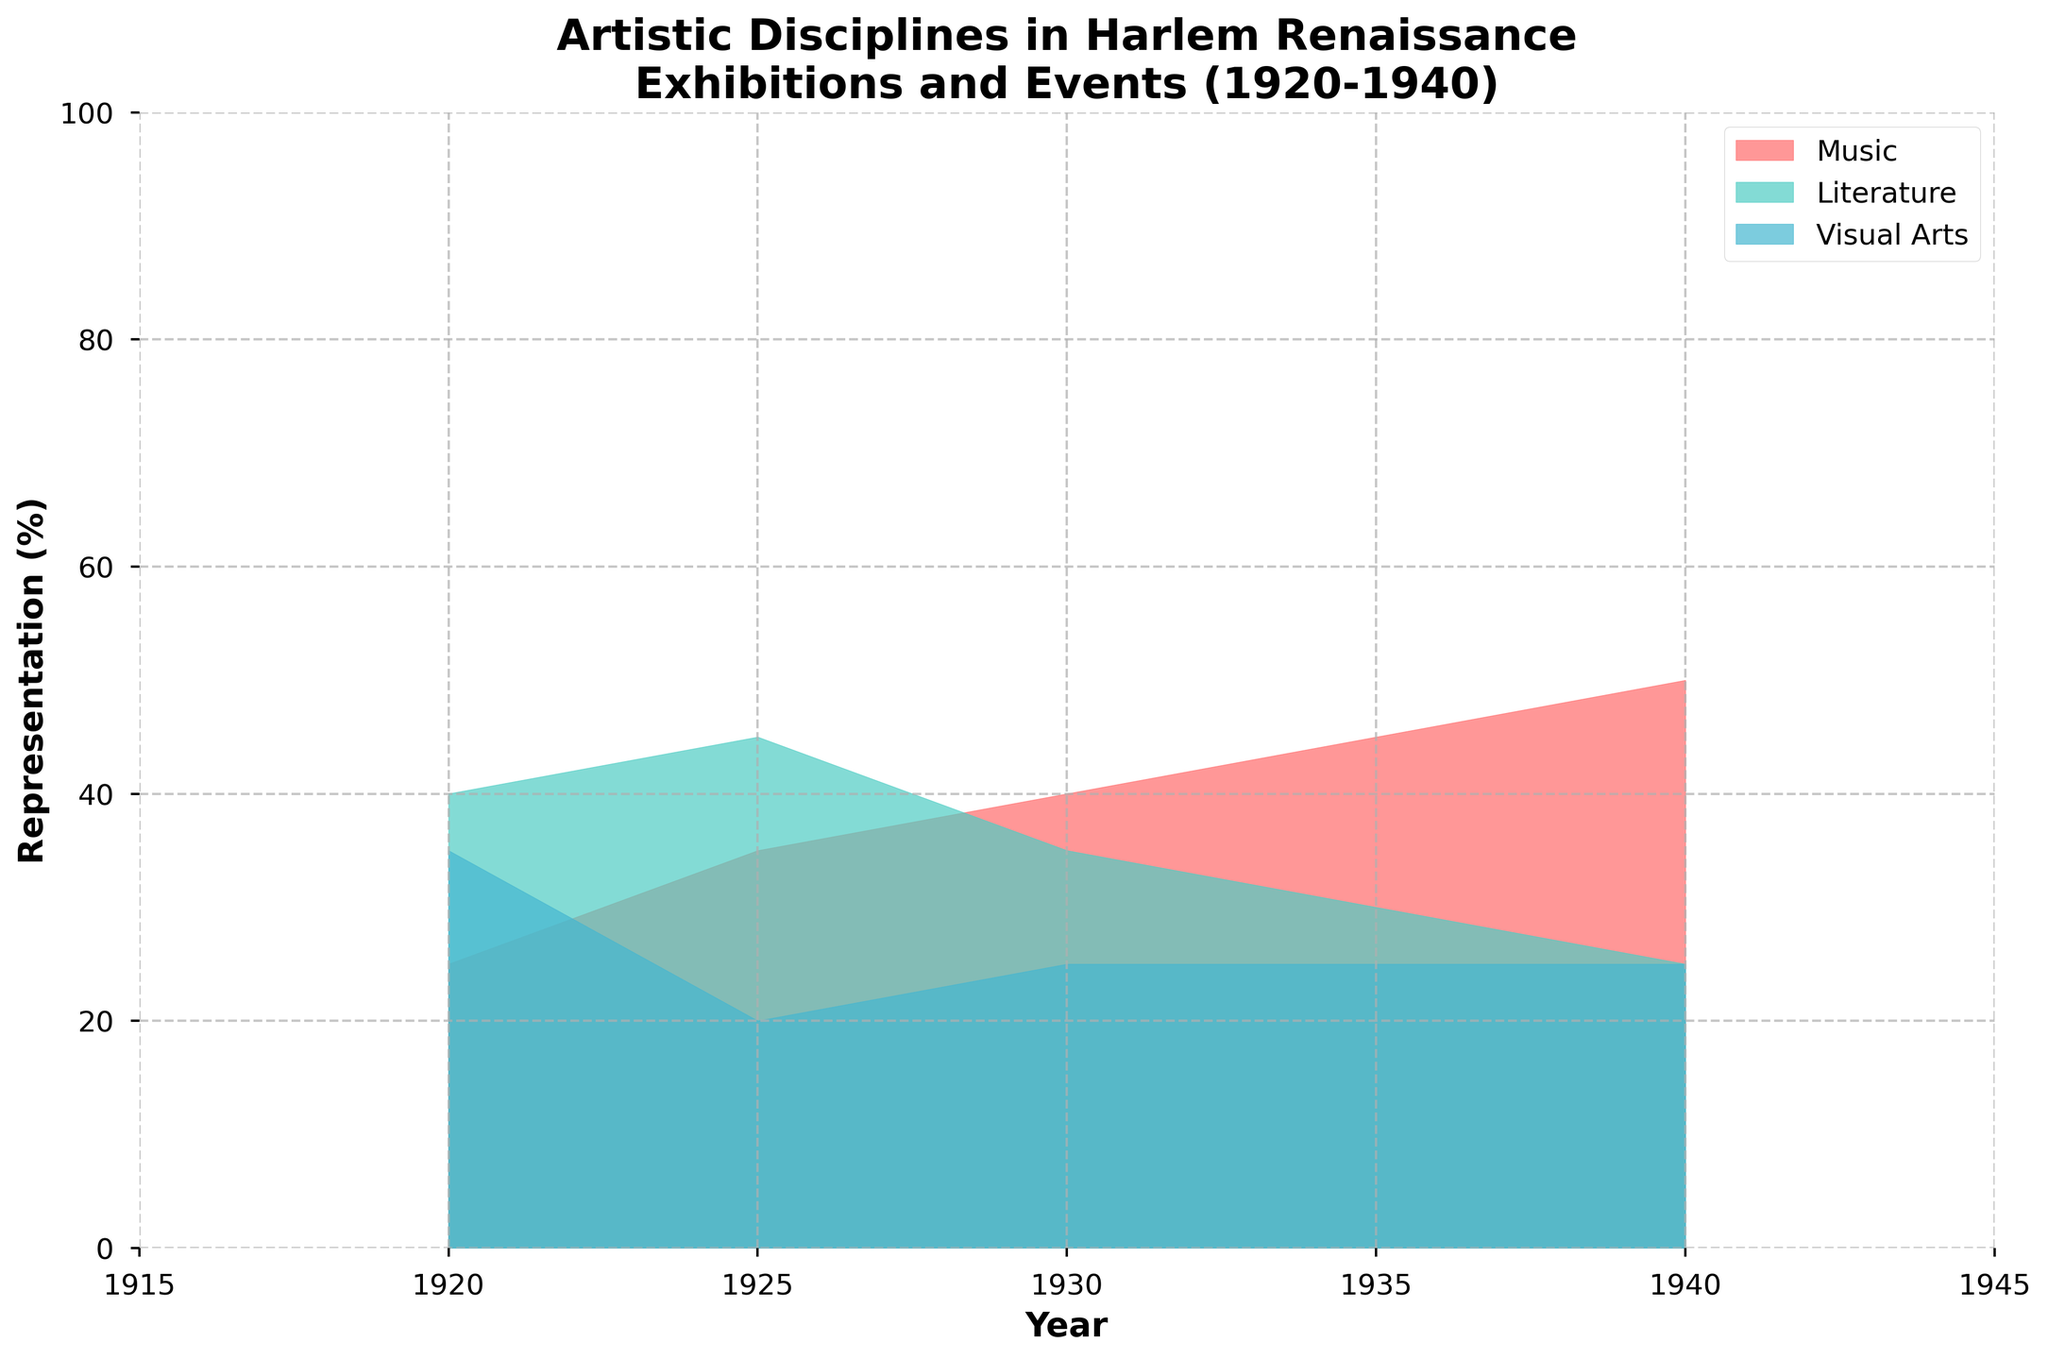What is the highest representation percentage across all disciplines in 1940? The maximum representation for any discipline in 1940 can be identified directly from the chart. The largest value observed is for Music at 50%.
Answer: 50% Which discipline had the lowest representation in 1925? By examining the representation values for each discipline in 1925, Music = 35%, Literature = 45%, Visual Arts = 20%. The lowest percentage is for Visual Arts.
Answer: Visual Arts What is the average representation of Literature in the given time period? Sum the representation values for Literature (40, 45, 35, 30, 25) and then divide by the number of years (5). Average = (40 + 45 + 35 + 30 + 25) / 5 = 35.
Answer: 35% Between Music and Visual Arts, which discipline had a higher average representation over the entire period? Calculate the average representation for both disciplines: 
Music: (25 + 35 + 40 + 45 + 50) / 5 = 39%
Visual Arts: (35 + 20 + 25 + 25 + 25) / 5 = 26%.
Compare the averages, and Music has the higher average representation.
Answer: Music During which year did Visual Arts representation drop the most compared to the previous year? Compare the Visual Arts representation year over year: 
1925: 35 - 25 = 10 decrease
1930: 25 - 20 = 5 increase
1935: 25 - 25 = 0 same
1940: 25 - 25 = 0 same
So, the biggest drop is in 1925.
Answer: 1925 How does the trend of the Music discipline change from 1920 to 1940? Review the representation values for Music over the years 1920, 1925, 1930, 1935, and 1940, it has continuously increased from 25% to 50% indicating a steady growth.
Answer: Increasing Which discipline shows a consistent representation across the years with minimal fluctuations? Compare the yearly representation of each discipline, Visual Arts percentages are 35, 20, 25, 25, 25, showing the least variation compared to others.
Answer: Visual Arts In what year are all the disciplines equally represented? In 1940, all disciplines have the same representation (50% Music, 25% Literature, 25% Visual Arts).
Answer: 1940 Which discipline shows the most fluctuation over the period? Calculate the range (maximum-minimum) for each discipline:
Music: 50 - 25 = 25
Literature: 45 - 25 = 20
Visual Arts: 35 - 20 = 15 
Music has the highest range, indicating the most fluctuation.
Answer: Music What can be inferred about the popularity trends of Literature from 1920 to 1940? By looking at the representation values of Literature (40, 45, 35, 30, 25), it shows a gradually decreasing trend over the years.
Answer: Decreasing Which discipline had the highest overall growth in representation from 1920 to 1940? Calculate the difference between the 1940 and 1920 values for each discipline:
Music: 50 - 25 = 25
Literature: 25 - 40 = -15
Visual Arts: 25 - 35 = -10.
Music shows the highest growth (25%).
Answer: Music 